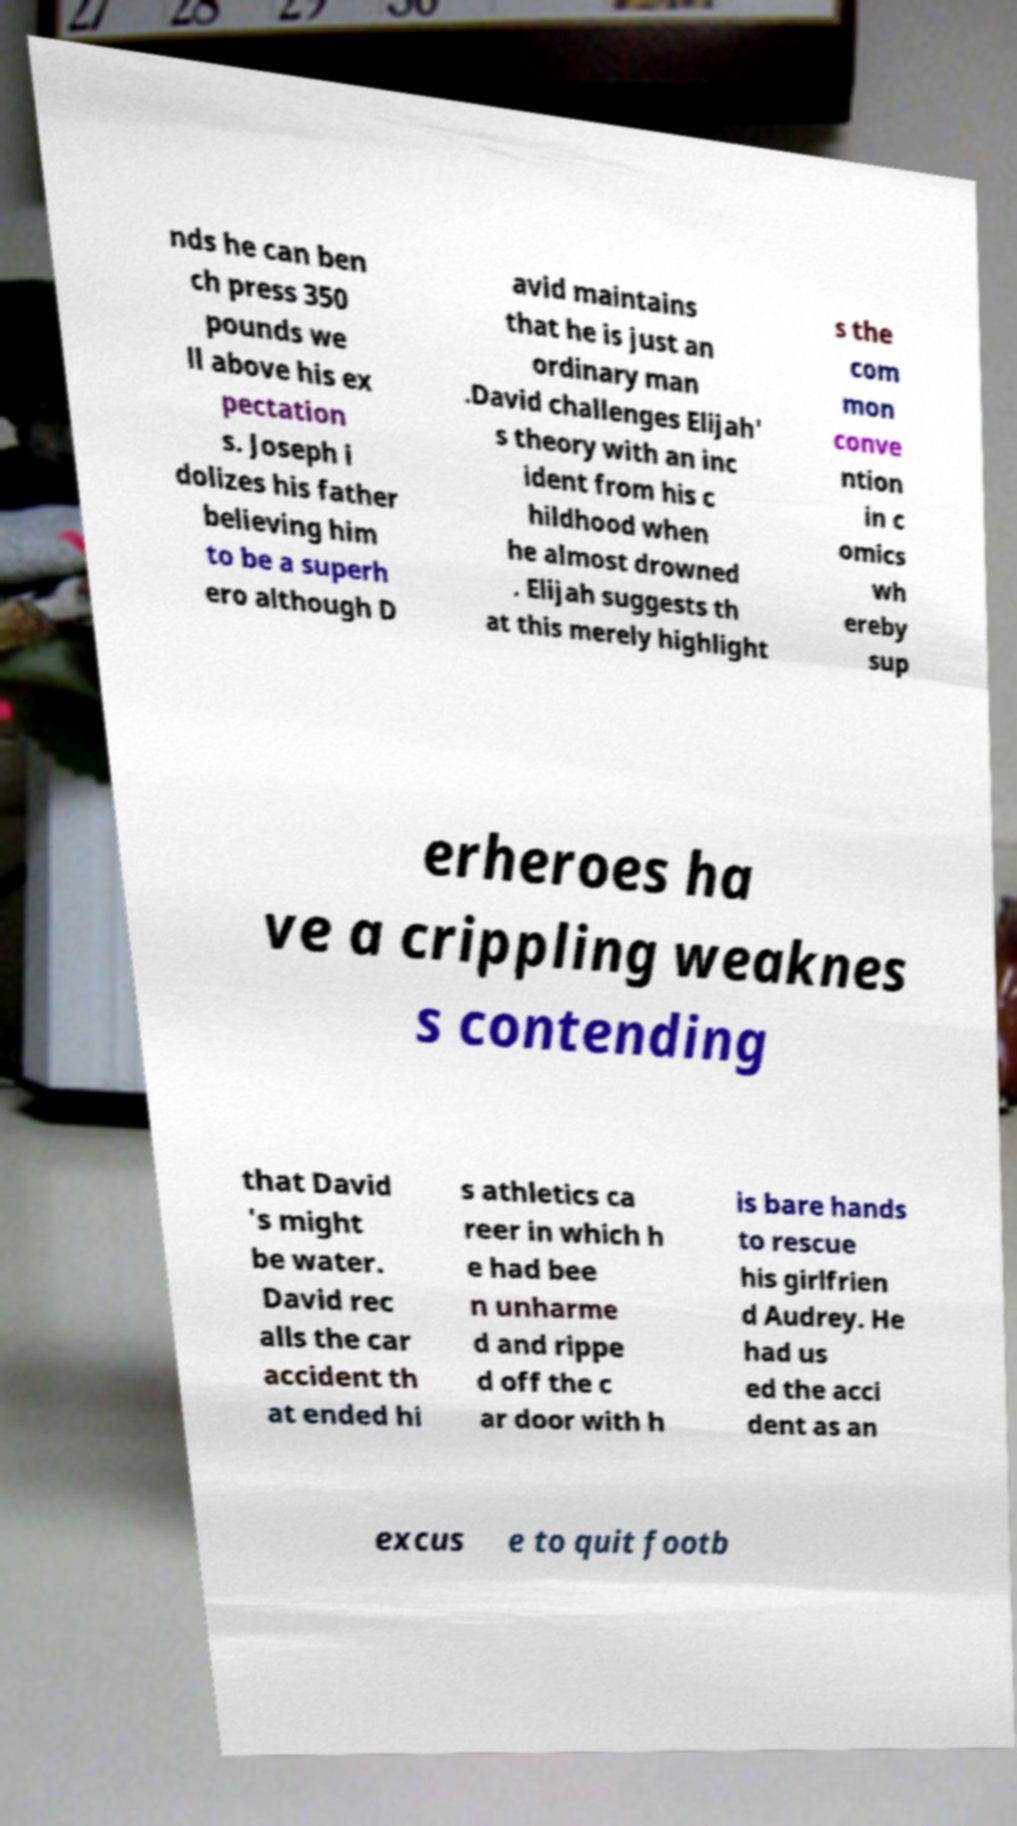What messages or text are displayed in this image? I need them in a readable, typed format. nds he can ben ch press 350 pounds we ll above his ex pectation s. Joseph i dolizes his father believing him to be a superh ero although D avid maintains that he is just an ordinary man .David challenges Elijah' s theory with an inc ident from his c hildhood when he almost drowned . Elijah suggests th at this merely highlight s the com mon conve ntion in c omics wh ereby sup erheroes ha ve a crippling weaknes s contending that David 's might be water. David rec alls the car accident th at ended hi s athletics ca reer in which h e had bee n unharme d and rippe d off the c ar door with h is bare hands to rescue his girlfrien d Audrey. He had us ed the acci dent as an excus e to quit footb 